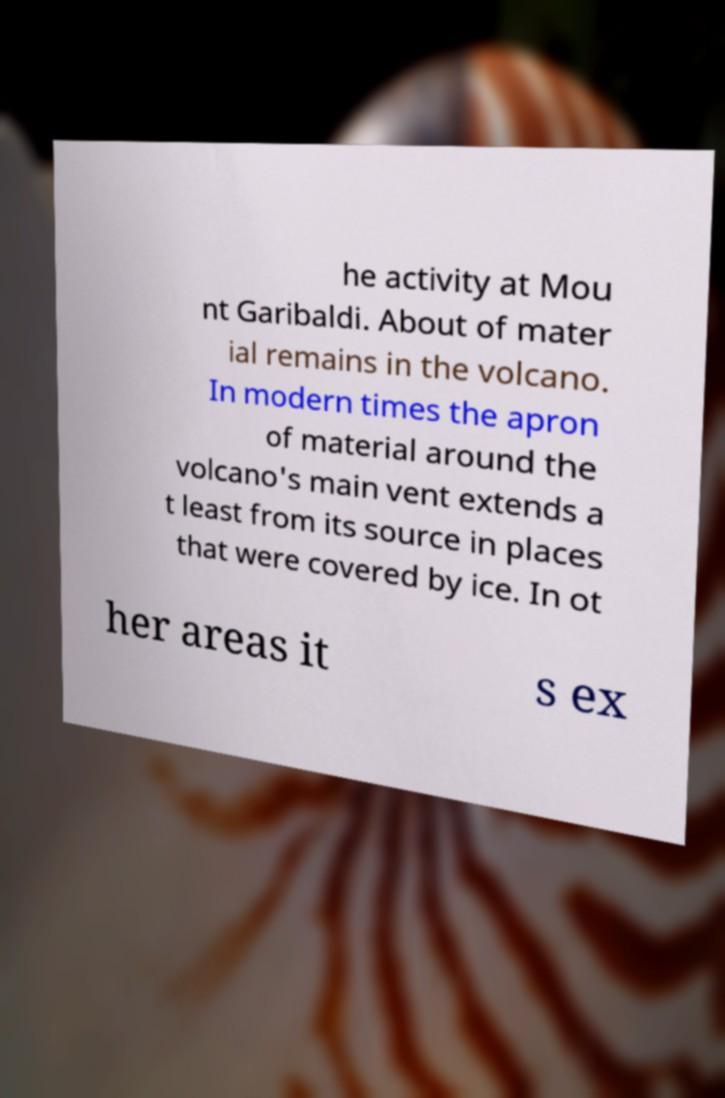Could you assist in decoding the text presented in this image and type it out clearly? he activity at Mou nt Garibaldi. About of mater ial remains in the volcano. In modern times the apron of material around the volcano's main vent extends a t least from its source in places that were covered by ice. In ot her areas it s ex 